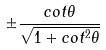Convert formula to latex. <formula><loc_0><loc_0><loc_500><loc_500>\pm \frac { c o t \theta } { \sqrt { 1 + c o t ^ { 2 } \theta } }</formula> 